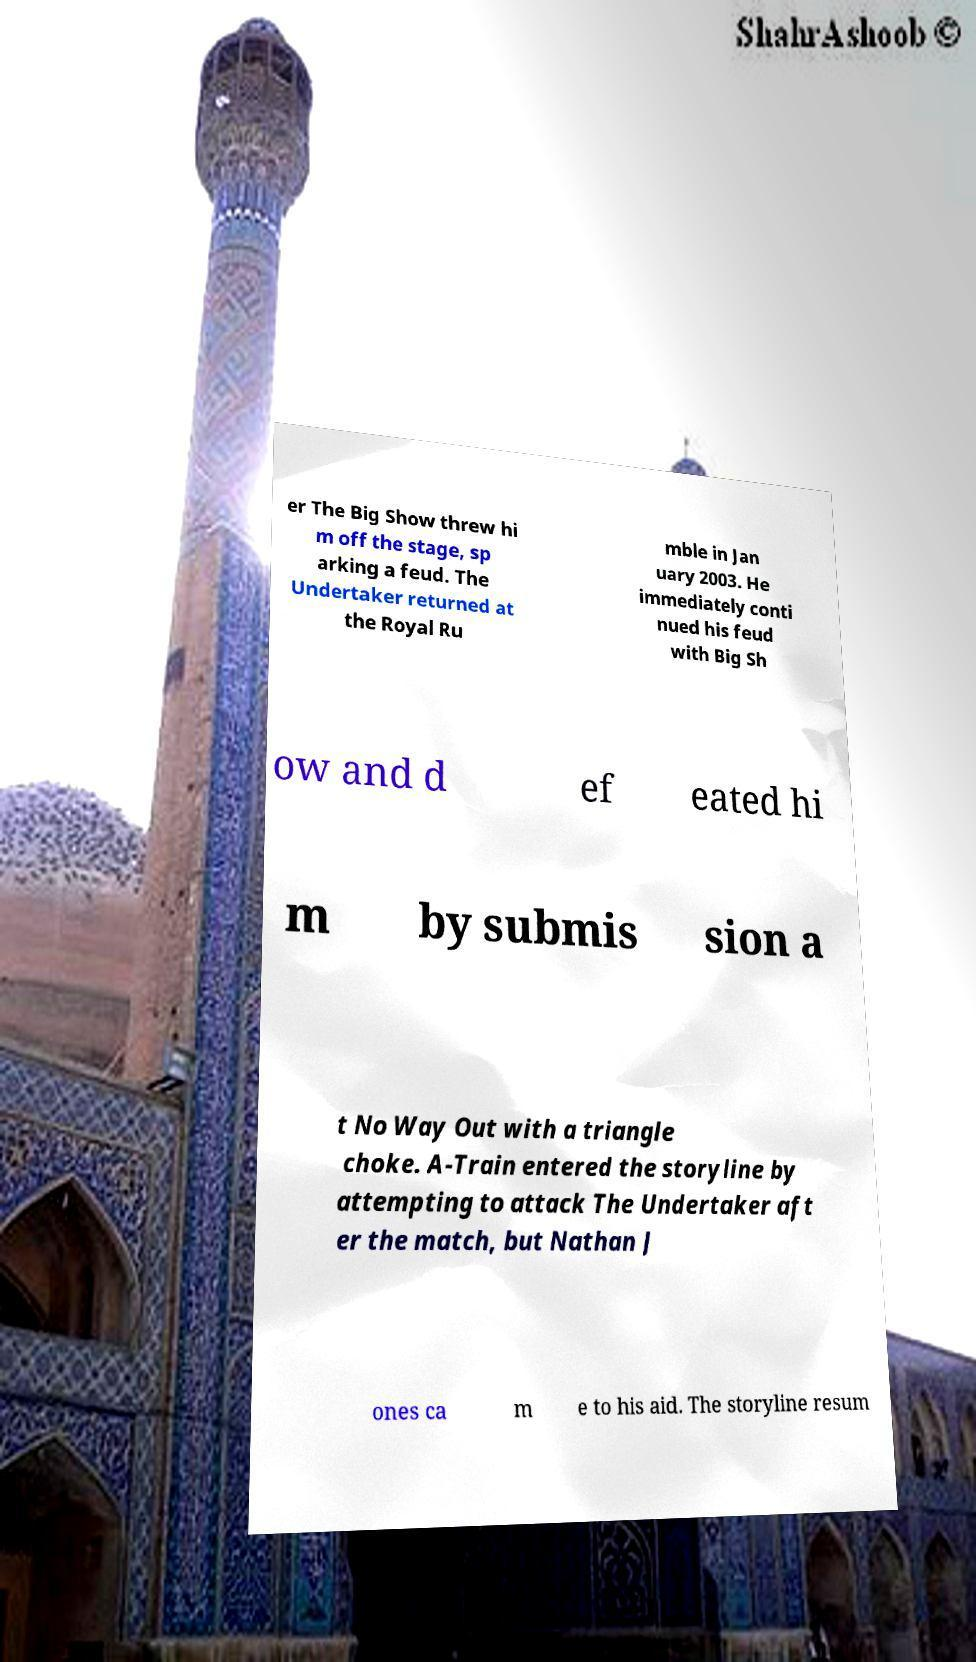Could you assist in decoding the text presented in this image and type it out clearly? er The Big Show threw hi m off the stage, sp arking a feud. The Undertaker returned at the Royal Ru mble in Jan uary 2003. He immediately conti nued his feud with Big Sh ow and d ef eated hi m by submis sion a t No Way Out with a triangle choke. A-Train entered the storyline by attempting to attack The Undertaker aft er the match, but Nathan J ones ca m e to his aid. The storyline resum 